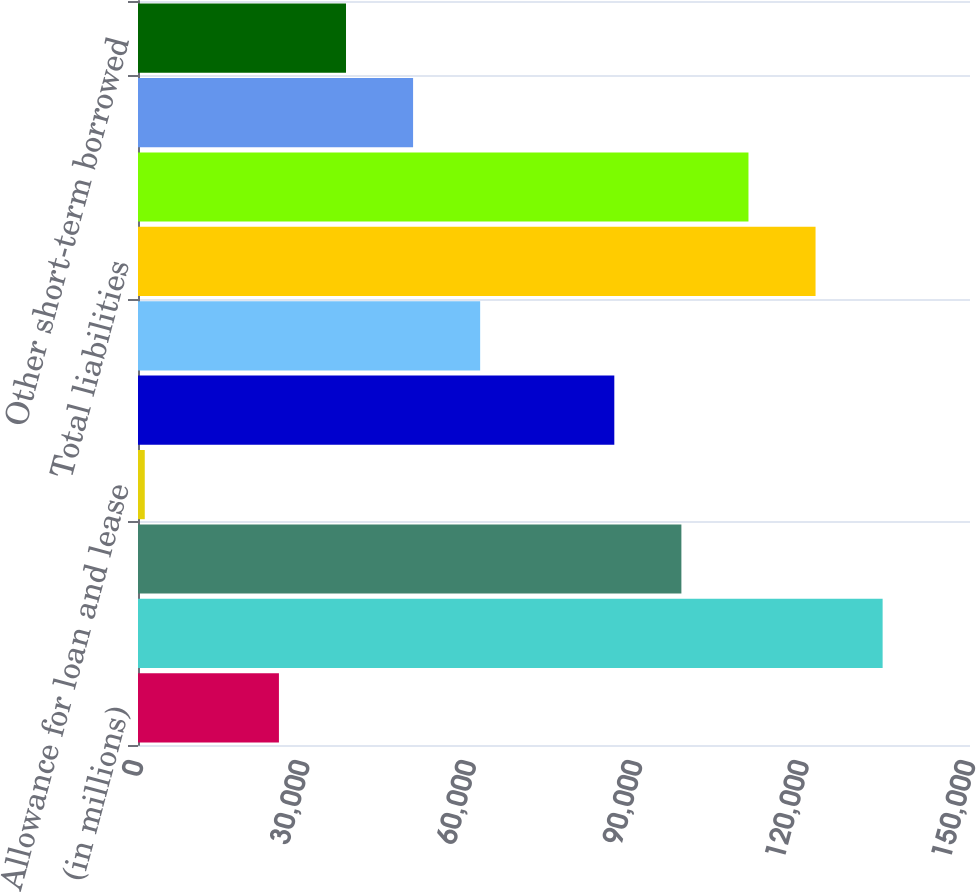Convert chart. <chart><loc_0><loc_0><loc_500><loc_500><bar_chart><fcel>(in millions)<fcel>Total assets<fcel>Loans and leases (6)<fcel>Allowance for loan and lease<fcel>Total securities<fcel>Goodwill<fcel>Total liabilities<fcel>Total deposits (7)<fcel>Federal funds purchased and<fcel>Other short-term borrowed<nl><fcel>25407.6<fcel>134247<fcel>97967.4<fcel>1221<fcel>85874.1<fcel>61687.5<fcel>122154<fcel>110061<fcel>49594.2<fcel>37500.9<nl></chart> 